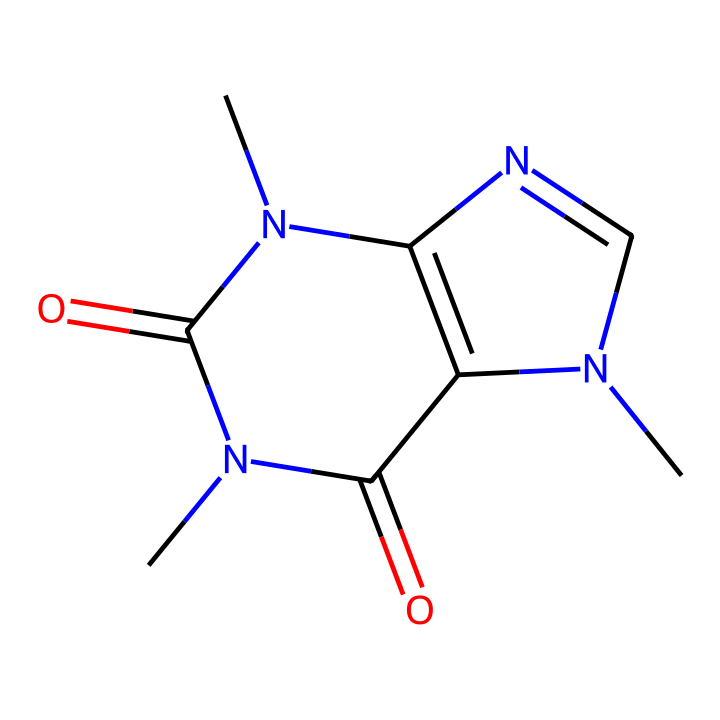What is the molecular formula of caffeine? By analyzing the chemical structure presented in the SMILES representation, we can count the atoms of each element. The structure contains 8 carbon (C) atoms, 10 hydrogen (H) atoms, 4 nitrogen (N) atoms, and 4 oxygen (O) atoms, leading to the molecular formula C8H10N4O2.
Answer: C8H10N4O2 How many rings are present in the structure of caffeine? Looking at the visual representation, we can count the distinct cyclic structures (rings) in the molecule. There are two fused rings present in the caffeine structure, indicating that the molecule contains a bicyclic system.
Answer: 2 What functional groups are present in caffeine? Examining the chemical structure indicates the presence of several functional groups, namely amide groups (-C(=O)N-) and a carbonyl group (C=O). Together, these groups are characteristic of the caffeine structure and its chemical behavior.
Answer: amide, carbonyl Does caffeine contain heteroatoms? In the provided chemical structure, we observe that it contains nitrogen (N) and oxygen (O) along with carbon (C) and hydrogen (H). The presence of N and O qualifies caffeine as having heteroatoms (atoms that are not carbon or hydrogen).
Answer: yes Which part of the caffeine structure affects its stimulant properties? Analyzing the caffeine structure, the methyl groups attached to the nitrogen atoms, which are characteristic of xanthines, enhance caffeine's ability to block adenosine receptors, thereby contributing to its stimulant effects.
Answer: methyl groups 